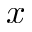<formula> <loc_0><loc_0><loc_500><loc_500>x</formula> 